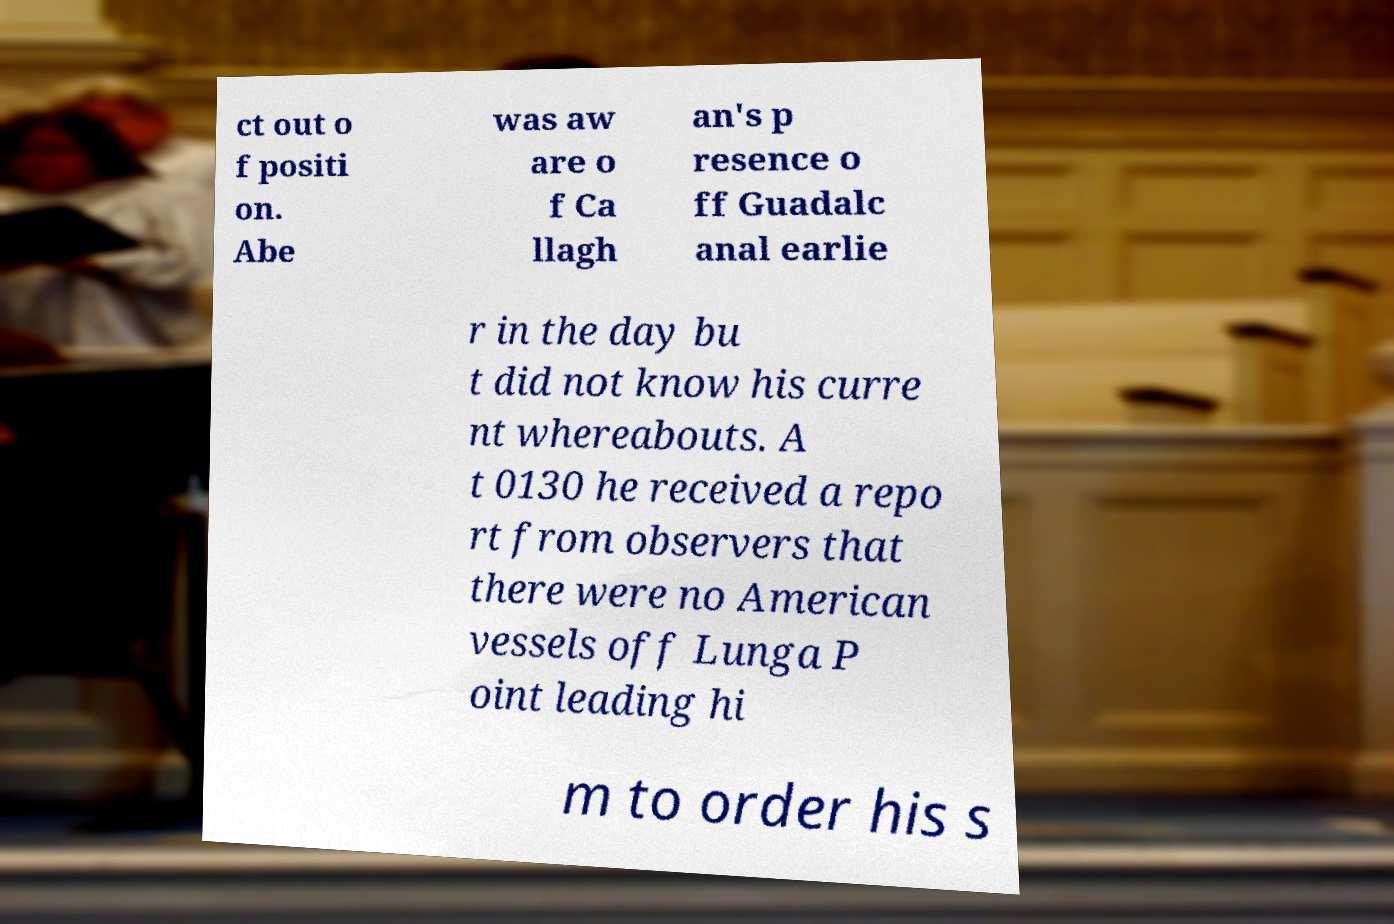Please identify and transcribe the text found in this image. ct out o f positi on. Abe was aw are o f Ca llagh an's p resence o ff Guadalc anal earlie r in the day bu t did not know his curre nt whereabouts. A t 0130 he received a repo rt from observers that there were no American vessels off Lunga P oint leading hi m to order his s 